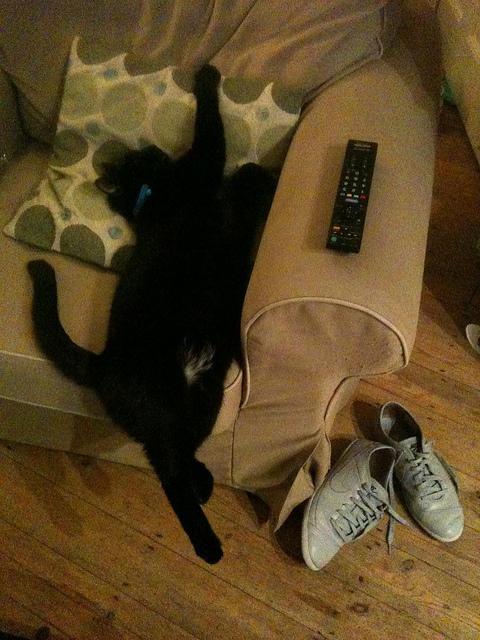What brand are the shoes on the ground?
Indicate the correct choice and explain in the format: 'Answer: answer
Rationale: rationale.'
Options: Vans, adidas, reebok, nike. Answer: nike.
Rationale: The shoes have a swoosh. 